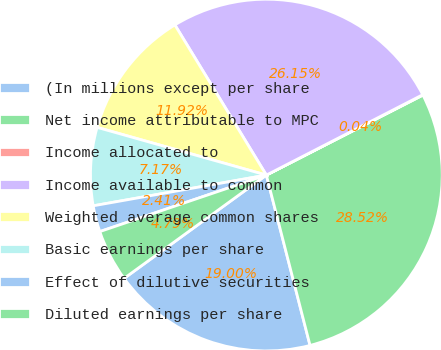Convert chart. <chart><loc_0><loc_0><loc_500><loc_500><pie_chart><fcel>(In millions except per share<fcel>Net income attributable to MPC<fcel>Income allocated to<fcel>Income available to common<fcel>Weighted average common shares<fcel>Basic earnings per share<fcel>Effect of dilutive securities<fcel>Diluted earnings per share<nl><fcel>19.0%<fcel>28.52%<fcel>0.04%<fcel>26.15%<fcel>11.92%<fcel>7.17%<fcel>2.41%<fcel>4.79%<nl></chart> 